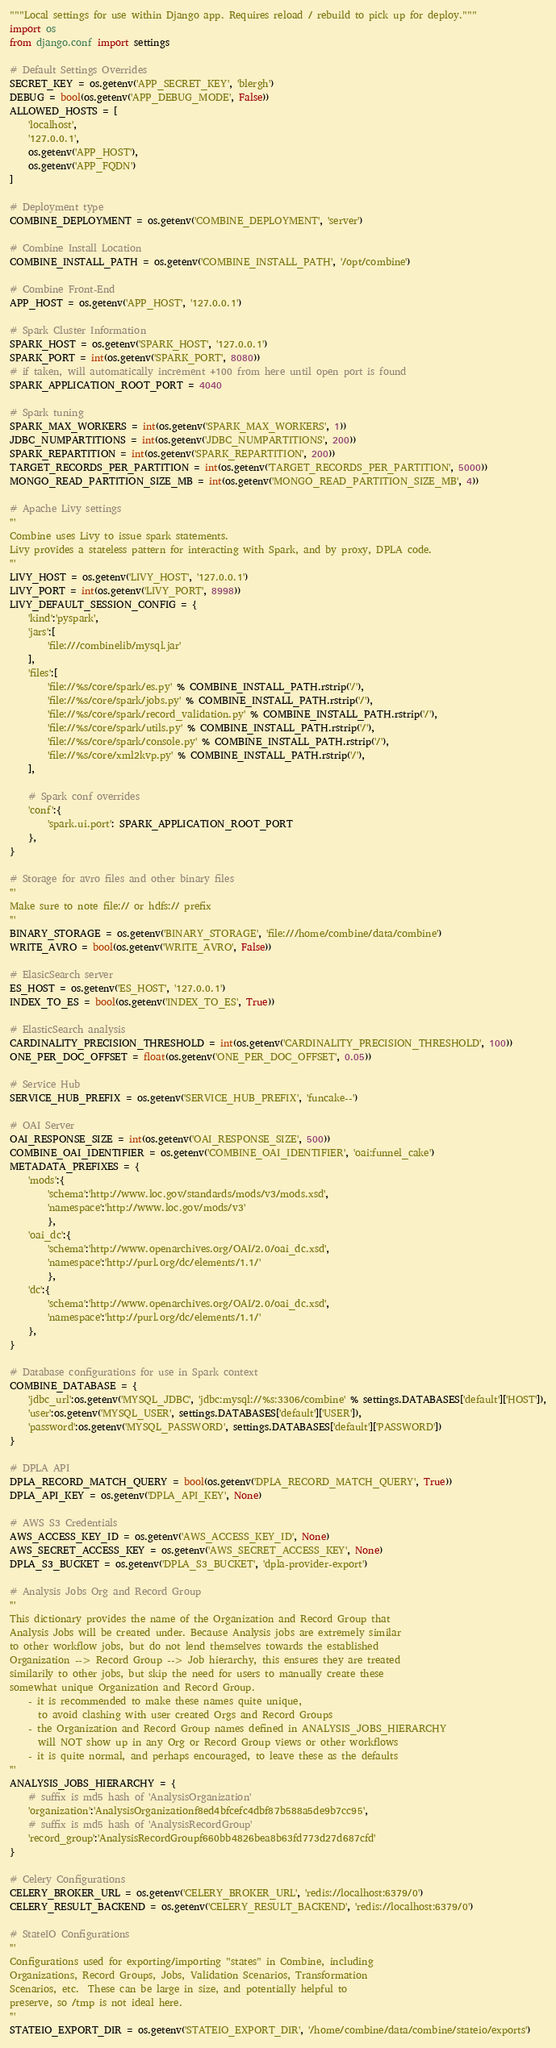<code> <loc_0><loc_0><loc_500><loc_500><_Python_>"""Local settings for use within Django app. Requires reload / rebuild to pick up for deploy."""
import os
from django.conf import settings

# Default Settings Overrides
SECRET_KEY = os.getenv('APP_SECRET_KEY', 'blergh')
DEBUG = bool(os.getenv('APP_DEBUG_MODE', False))
ALLOWED_HOSTS = [
    'localhost',
    '127.0.0.1',
    os.getenv('APP_HOST'),
    os.getenv('APP_FQDN')
]

# Deployment type
COMBINE_DEPLOYMENT = os.getenv('COMBINE_DEPLOYMENT', 'server')

# Combine Install Location
COMBINE_INSTALL_PATH = os.getenv('COMBINE_INSTALL_PATH', '/opt/combine')

# Combine Front-End
APP_HOST = os.getenv('APP_HOST', '127.0.0.1')

# Spark Cluster Information
SPARK_HOST = os.getenv('SPARK_HOST', '127.0.0.1')
SPARK_PORT = int(os.getenv('SPARK_PORT', 8080))
# if taken, will automatically increment +100 from here until open port is found
SPARK_APPLICATION_ROOT_PORT = 4040

# Spark tuning
SPARK_MAX_WORKERS = int(os.getenv('SPARK_MAX_WORKERS', 1))
JDBC_NUMPARTITIONS = int(os.getenv('JDBC_NUMPARTITIONS', 200))
SPARK_REPARTITION = int(os.getenv('SPARK_REPARTITION', 200))
TARGET_RECORDS_PER_PARTITION = int(os.getenv('TARGET_RECORDS_PER_PARTITION', 5000))
MONGO_READ_PARTITION_SIZE_MB = int(os.getenv('MONGO_READ_PARTITION_SIZE_MB', 4))

# Apache Livy settings
'''
Combine uses Livy to issue spark statements.
Livy provides a stateless pattern for interacting with Spark, and by proxy, DPLA code.
'''
LIVY_HOST = os.getenv('LIVY_HOST', '127.0.0.1')
LIVY_PORT = int(os.getenv('LIVY_PORT', 8998))
LIVY_DEFAULT_SESSION_CONFIG = {
    'kind':'pyspark',
    'jars':[
        'file:///combinelib/mysql.jar'
    ],
    'files':[
        'file://%s/core/spark/es.py' % COMBINE_INSTALL_PATH.rstrip('/'),
        'file://%s/core/spark/jobs.py' % COMBINE_INSTALL_PATH.rstrip('/'),
        'file://%s/core/spark/record_validation.py' % COMBINE_INSTALL_PATH.rstrip('/'),
        'file://%s/core/spark/utils.py' % COMBINE_INSTALL_PATH.rstrip('/'),
        'file://%s/core/spark/console.py' % COMBINE_INSTALL_PATH.rstrip('/'),
        'file://%s/core/xml2kvp.py' % COMBINE_INSTALL_PATH.rstrip('/'),
    ],

    # Spark conf overrides
    'conf':{
        'spark.ui.port': SPARK_APPLICATION_ROOT_PORT
    },
}

# Storage for avro files and other binary files
'''
Make sure to note file:// or hdfs:// prefix
'''
BINARY_STORAGE = os.getenv('BINARY_STORAGE', 'file:///home/combine/data/combine')
WRITE_AVRO = bool(os.getenv('WRITE_AVRO', False))

# ElasicSearch server
ES_HOST = os.getenv('ES_HOST', '127.0.0.1')
INDEX_TO_ES = bool(os.getenv('INDEX_TO_ES', True))

# ElasticSearch analysis
CARDINALITY_PRECISION_THRESHOLD = int(os.getenv('CARDINALITY_PRECISION_THRESHOLD', 100))
ONE_PER_DOC_OFFSET = float(os.getenv('ONE_PER_DOC_OFFSET', 0.05))

# Service Hub
SERVICE_HUB_PREFIX = os.getenv('SERVICE_HUB_PREFIX', 'funcake--')

# OAI Server
OAI_RESPONSE_SIZE = int(os.getenv('OAI_RESPONSE_SIZE', 500))
COMBINE_OAI_IDENTIFIER = os.getenv('COMBINE_OAI_IDENTIFIER', 'oai:funnel_cake')
METADATA_PREFIXES = {
    'mods':{
        'schema':'http://www.loc.gov/standards/mods/v3/mods.xsd',
        'namespace':'http://www.loc.gov/mods/v3'
        },
    'oai_dc':{
        'schema':'http://www.openarchives.org/OAI/2.0/oai_dc.xsd',
        'namespace':'http://purl.org/dc/elements/1.1/'
        },
    'dc':{
        'schema':'http://www.openarchives.org/OAI/2.0/oai_dc.xsd',
        'namespace':'http://purl.org/dc/elements/1.1/'
    },
}

# Database configurations for use in Spark context
COMBINE_DATABASE = {
    'jdbc_url':os.getenv('MYSQL_JDBC', 'jdbc:mysql://%s:3306/combine' % settings.DATABASES['default']['HOST']),
    'user':os.getenv('MYSQL_USER', settings.DATABASES['default']['USER']),
    'password':os.getenv('MYSQL_PASSWORD', settings.DATABASES['default']['PASSWORD'])
}

# DPLA API
DPLA_RECORD_MATCH_QUERY = bool(os.getenv('DPLA_RECORD_MATCH_QUERY', True))
DPLA_API_KEY = os.getenv('DPLA_API_KEY', None)

# AWS S3 Credentials
AWS_ACCESS_KEY_ID = os.getenv('AWS_ACCESS_KEY_ID', None)
AWS_SECRET_ACCESS_KEY = os.getenv('AWS_SECRET_ACCESS_KEY', None)
DPLA_S3_BUCKET = os.getenv('DPLA_S3_BUCKET', 'dpla-provider-export')

# Analysis Jobs Org and Record Group
'''
This dictionary provides the name of the Organization and Record Group that
Analysis Jobs will be created under. Because Analysis jobs are extremely similar
to other workflow jobs, but do not lend themselves towards the established
Organization --> Record Group --> Job hierarchy, this ensures they are treated
similarily to other jobs, but skip the need for users to manually create these
somewhat unique Organization and Record Group.
    - it is recommended to make these names quite unique,
      to avoid clashing with user created Orgs and Record Groups
    - the Organization and Record Group names defined in ANALYSIS_JOBS_HIERARCHY
      will NOT show up in any Org or Record Group views or other workflows
	- it is quite normal, and perhaps encouraged, to leave these as the defaults
'''
ANALYSIS_JOBS_HIERARCHY = {
    # suffix is md5 hash of 'AnalysisOrganization'
    'organization':'AnalysisOrganizationf8ed4bfcefc4dbf87b588a5de9b7cc95',
    # suffix is md5 hash of 'AnalysisRecordGroup'
    'record_group':'AnalysisRecordGroupf660bb4826bea8b63fd773d27d687cfd'
}

# Celery Configurations
CELERY_BROKER_URL = os.getenv('CELERY_BROKER_URL', 'redis://localhost:6379/0')
CELERY_RESULT_BACKEND = os.getenv('CELERY_RESULT_BACKEND', 'redis://localhost:6379/0')

# StateIO Configurations
'''
Configurations used for exporting/importing "states" in Combine, including
Organizations, Record Groups, Jobs, Validation Scenarios, Transformation
Scenarios, etc.  These can be large in size, and potentially helpful to
preserve, so /tmp is not ideal here.
'''
STATEIO_EXPORT_DIR = os.getenv('STATEIO_EXPORT_DIR', '/home/combine/data/combine/stateio/exports')</code> 